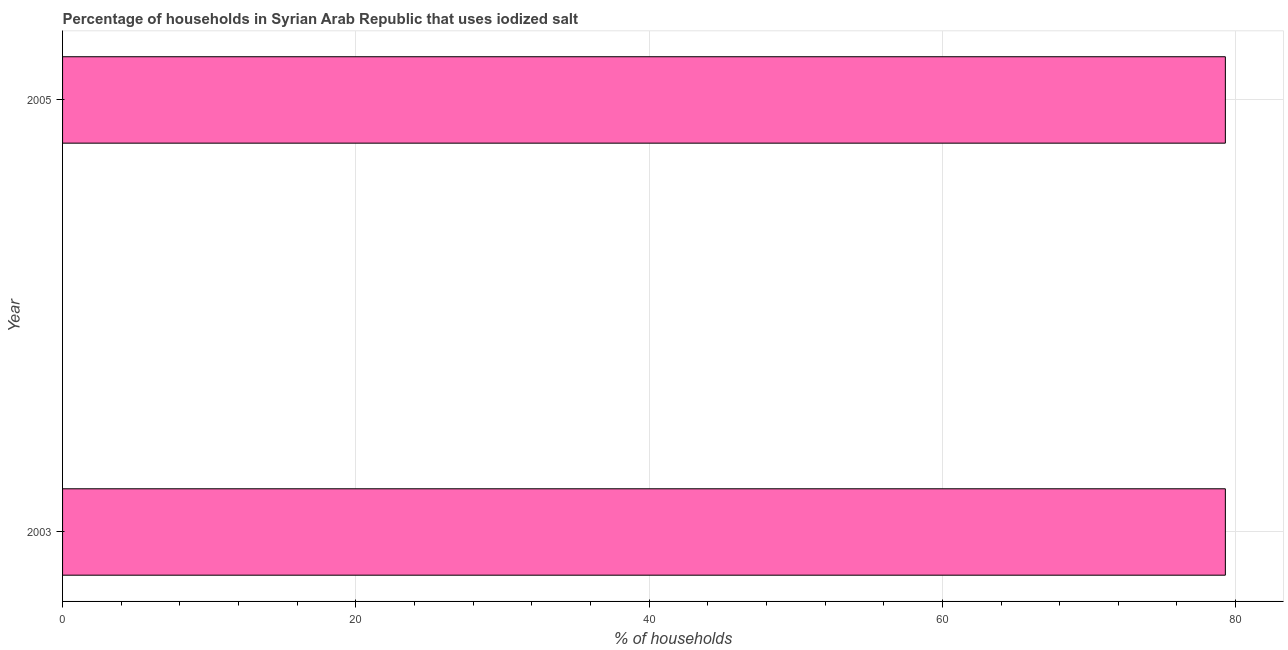What is the title of the graph?
Provide a succinct answer. Percentage of households in Syrian Arab Republic that uses iodized salt. What is the label or title of the X-axis?
Offer a very short reply. % of households. What is the label or title of the Y-axis?
Make the answer very short. Year. What is the percentage of households where iodized salt is consumed in 2005?
Offer a very short reply. 79.3. Across all years, what is the maximum percentage of households where iodized salt is consumed?
Your answer should be compact. 79.3. Across all years, what is the minimum percentage of households where iodized salt is consumed?
Your answer should be very brief. 79.3. In which year was the percentage of households where iodized salt is consumed maximum?
Provide a short and direct response. 2003. In which year was the percentage of households where iodized salt is consumed minimum?
Give a very brief answer. 2003. What is the sum of the percentage of households where iodized salt is consumed?
Provide a succinct answer. 158.6. What is the average percentage of households where iodized salt is consumed per year?
Offer a very short reply. 79.3. What is the median percentage of households where iodized salt is consumed?
Keep it short and to the point. 79.3. In how many years, is the percentage of households where iodized salt is consumed greater than 60 %?
Keep it short and to the point. 2. What is the ratio of the percentage of households where iodized salt is consumed in 2003 to that in 2005?
Provide a short and direct response. 1. Is the percentage of households where iodized salt is consumed in 2003 less than that in 2005?
Offer a very short reply. No. How many bars are there?
Offer a terse response. 2. How many years are there in the graph?
Make the answer very short. 2. What is the difference between two consecutive major ticks on the X-axis?
Offer a terse response. 20. Are the values on the major ticks of X-axis written in scientific E-notation?
Your answer should be compact. No. What is the % of households of 2003?
Give a very brief answer. 79.3. What is the % of households in 2005?
Your response must be concise. 79.3. What is the difference between the % of households in 2003 and 2005?
Your answer should be compact. 0. What is the ratio of the % of households in 2003 to that in 2005?
Offer a terse response. 1. 